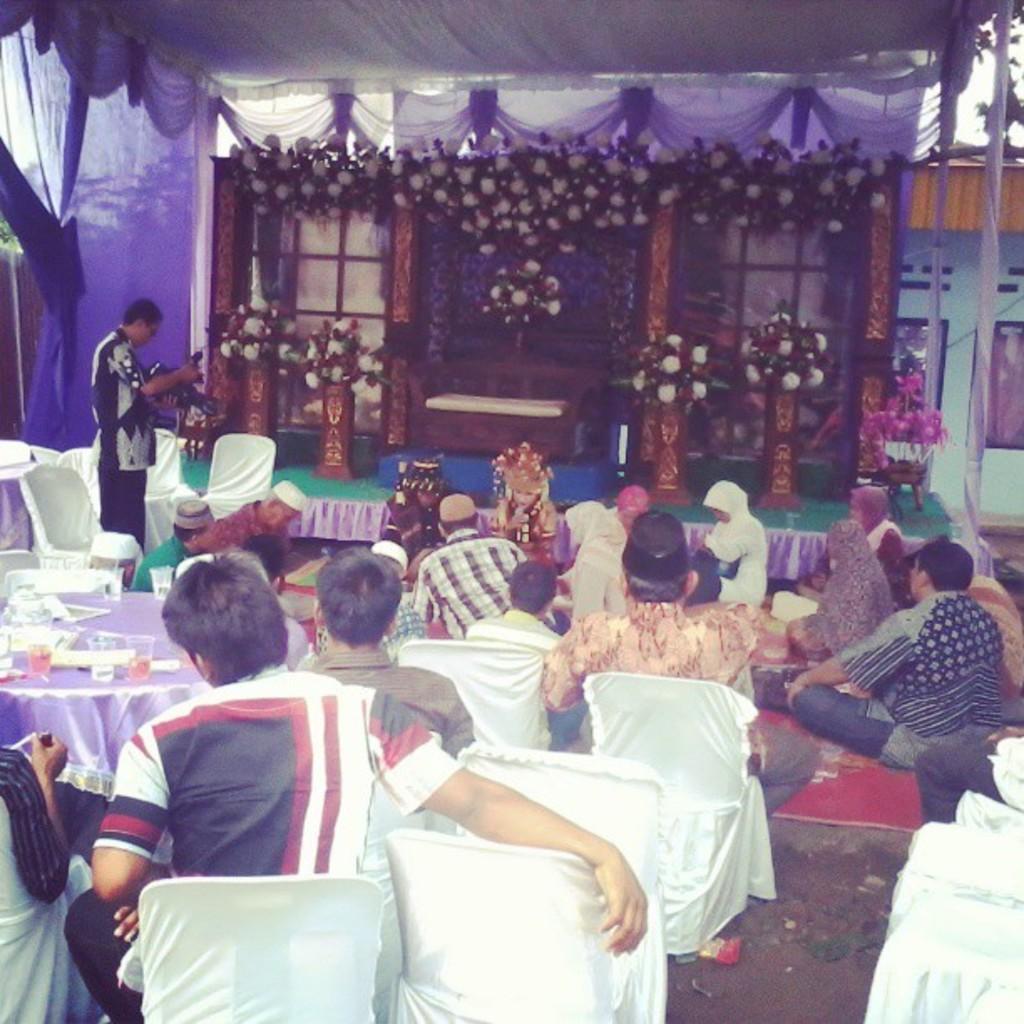In one or two sentences, can you explain what this image depicts? In this picture we can see group of persons sitting on the carpet. Here we can see a boy who is wearing white shirt and trouser. He is sitting on the chair and in front of him we can see another man who is wearing shirt. He is sitting near to the table. On the table we can see juice glass, water glass, papers and other objects. Here we can see white cloth which are covered on chairs. On the stage we can see steel pots and different color flowers. Here we can see couch. On the top there is a tent. On the top right corner there is a tree and sky. Here we can see windows. On the left there is a cameraman who is holding a camera. 